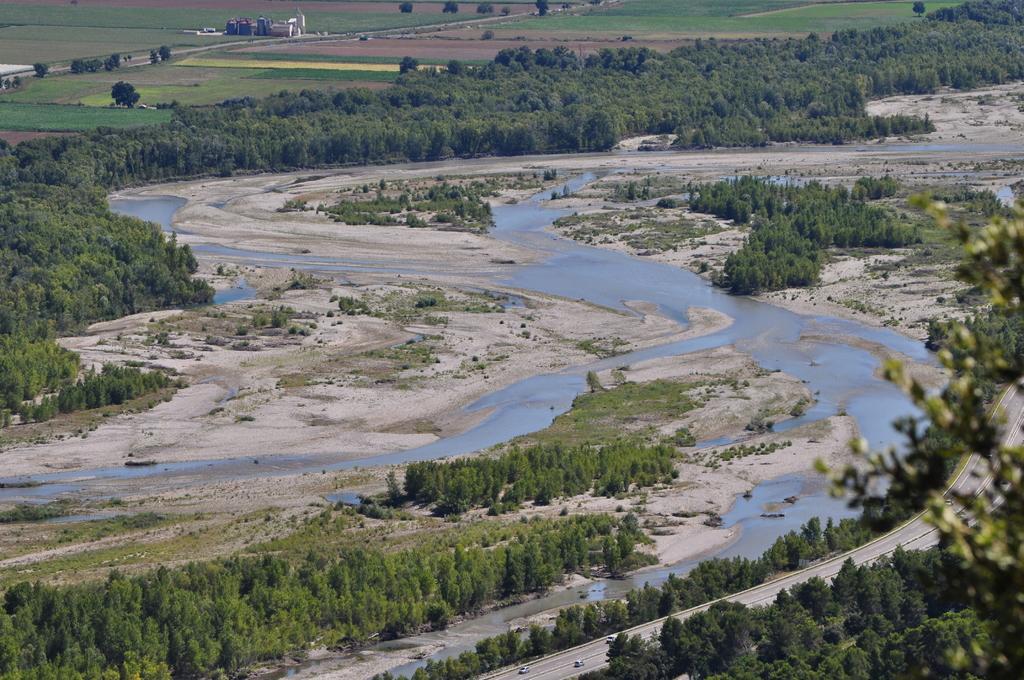Could you give a brief overview of what you see in this image? In this picture we can see water, trees and few vehicles on the road, in the background we can find few houses. 